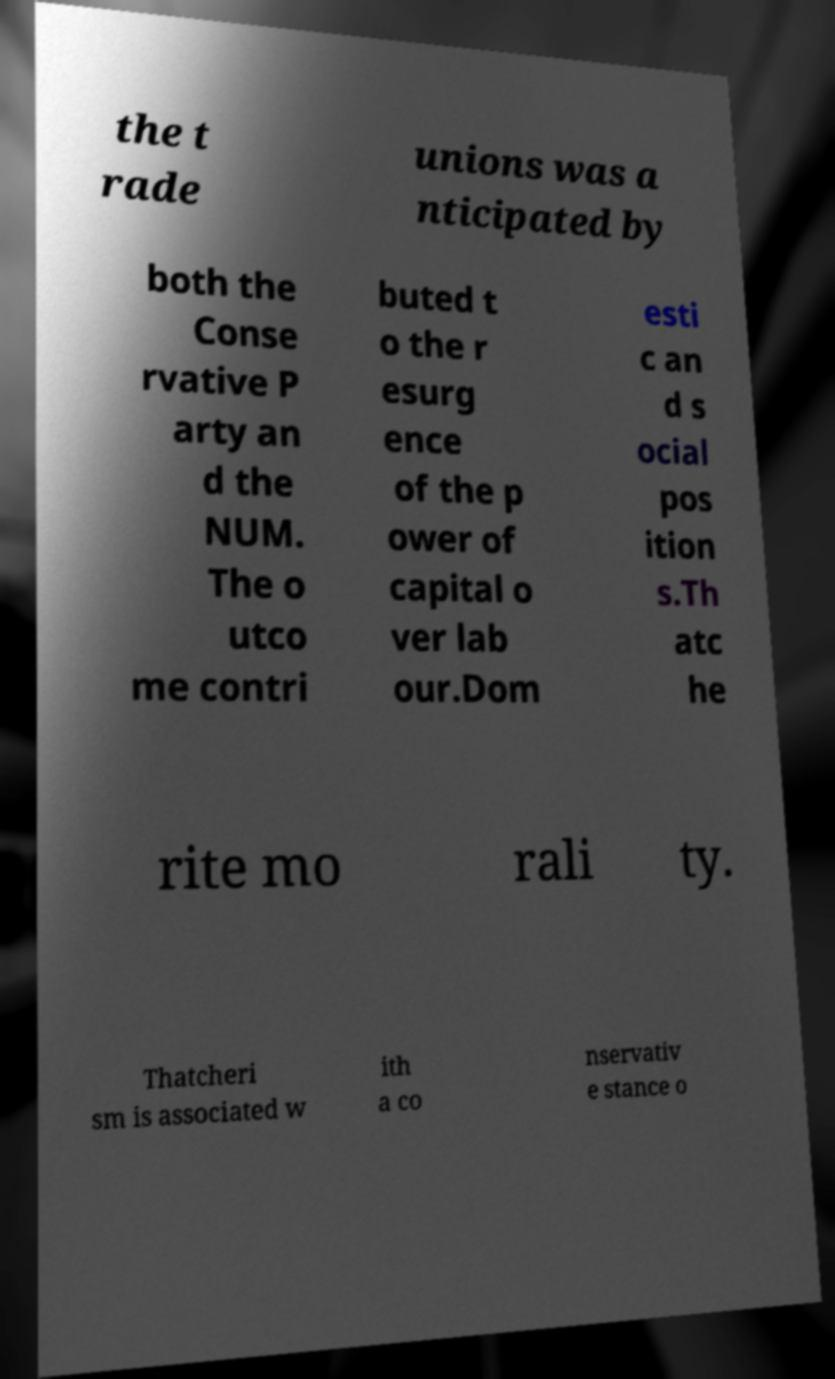Can you read and provide the text displayed in the image?This photo seems to have some interesting text. Can you extract and type it out for me? the t rade unions was a nticipated by both the Conse rvative P arty an d the NUM. The o utco me contri buted t o the r esurg ence of the p ower of capital o ver lab our.Dom esti c an d s ocial pos ition s.Th atc he rite mo rali ty. Thatcheri sm is associated w ith a co nservativ e stance o 